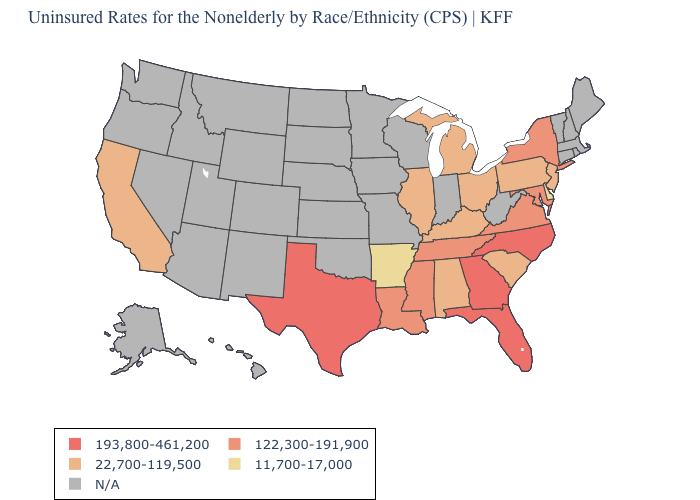What is the highest value in the South ?
Short answer required. 193,800-461,200. Is the legend a continuous bar?
Write a very short answer. No. What is the value of Ohio?
Short answer required. 22,700-119,500. Does the map have missing data?
Concise answer only. Yes. Does the first symbol in the legend represent the smallest category?
Short answer required. No. What is the value of Idaho?
Be succinct. N/A. Does Florida have the highest value in the USA?
Quick response, please. Yes. Does the map have missing data?
Concise answer only. Yes. Among the states that border Maryland , does Virginia have the highest value?
Quick response, please. Yes. What is the lowest value in states that border Pennsylvania?
Keep it brief. 11,700-17,000. How many symbols are there in the legend?
Be succinct. 5. Name the states that have a value in the range 193,800-461,200?
Write a very short answer. Florida, Georgia, North Carolina, Texas. Name the states that have a value in the range 122,300-191,900?
Be succinct. Louisiana, Maryland, Mississippi, New York, Tennessee, Virginia. 